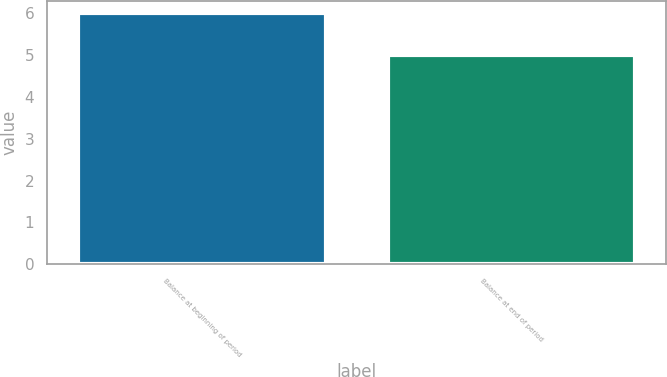Convert chart. <chart><loc_0><loc_0><loc_500><loc_500><bar_chart><fcel>Balance at beginning of period<fcel>Balance at end of period<nl><fcel>6<fcel>5<nl></chart> 